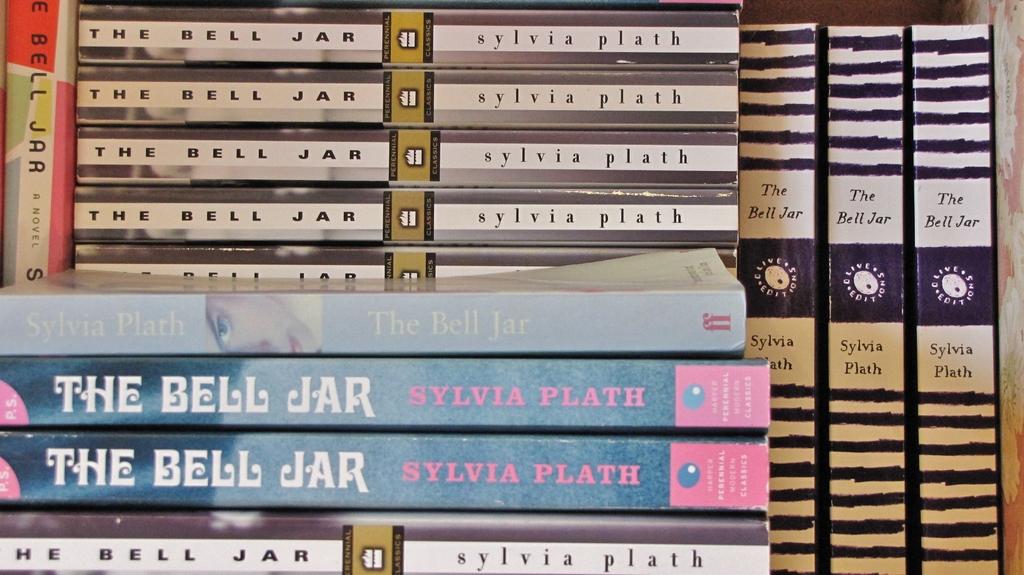What is the title of all the books?
Your answer should be very brief. The bell jar. 